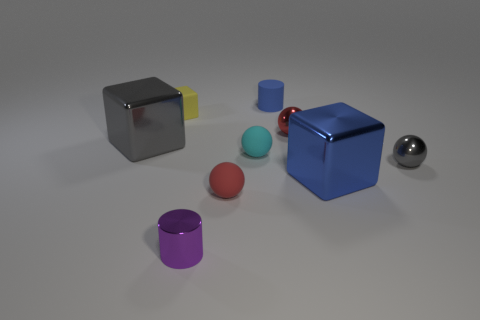Is there anything about the lighting in this scene that is notable? The lighting in the scene is soft and diffused, creating gentle shadows that give the objects dimension and emphasize their geometric shapes without harsh contrasts. Could you guess the time of day or setting based on the lighting? Given the neutral background and controlled lighting, it's likely that this image is set in an indoor environment with artificial lighting, rather than being indicative of any particular time of day. 